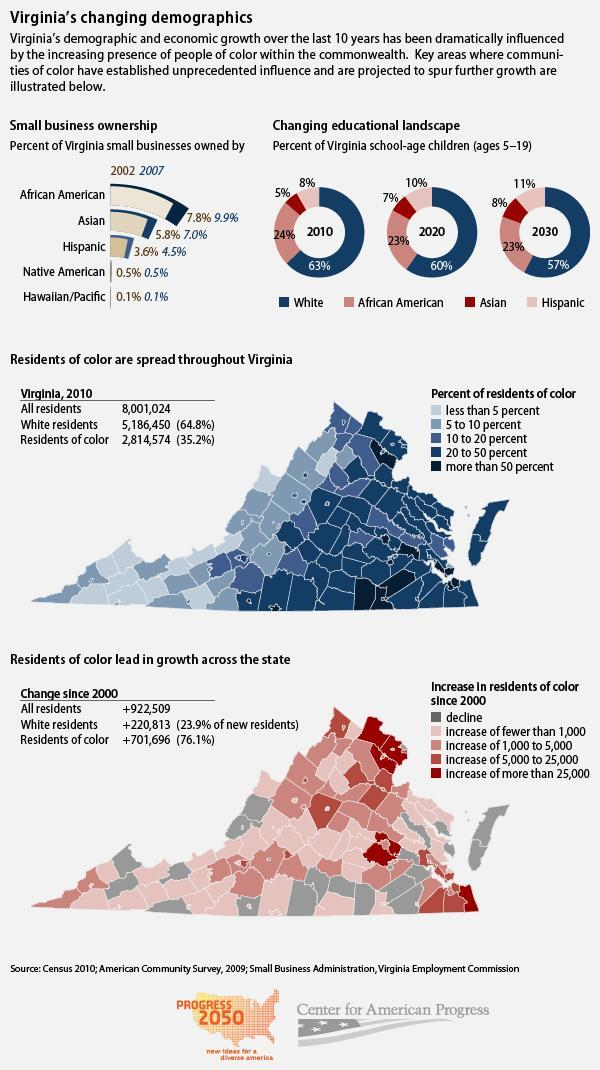What is the percentage of Virginia school-age children who are African Americans in 2030 and 2020, taken together?
Answer the question with a short phrase. 46% What is the percentage of Virginia school-age children who are Asians in 2010 and 2020, taken together? 12% What is the percentage of Virginia school-age children who are white in 2010 and 2020, taken together? 123% What is the percentage of Virginia small businesses owned by African Americans in 2002 and 2007, taken together? 17.7% What is the percentage of Virginia small businesses owned by Asians in 2002 and 2007, taken together? 12.8% 